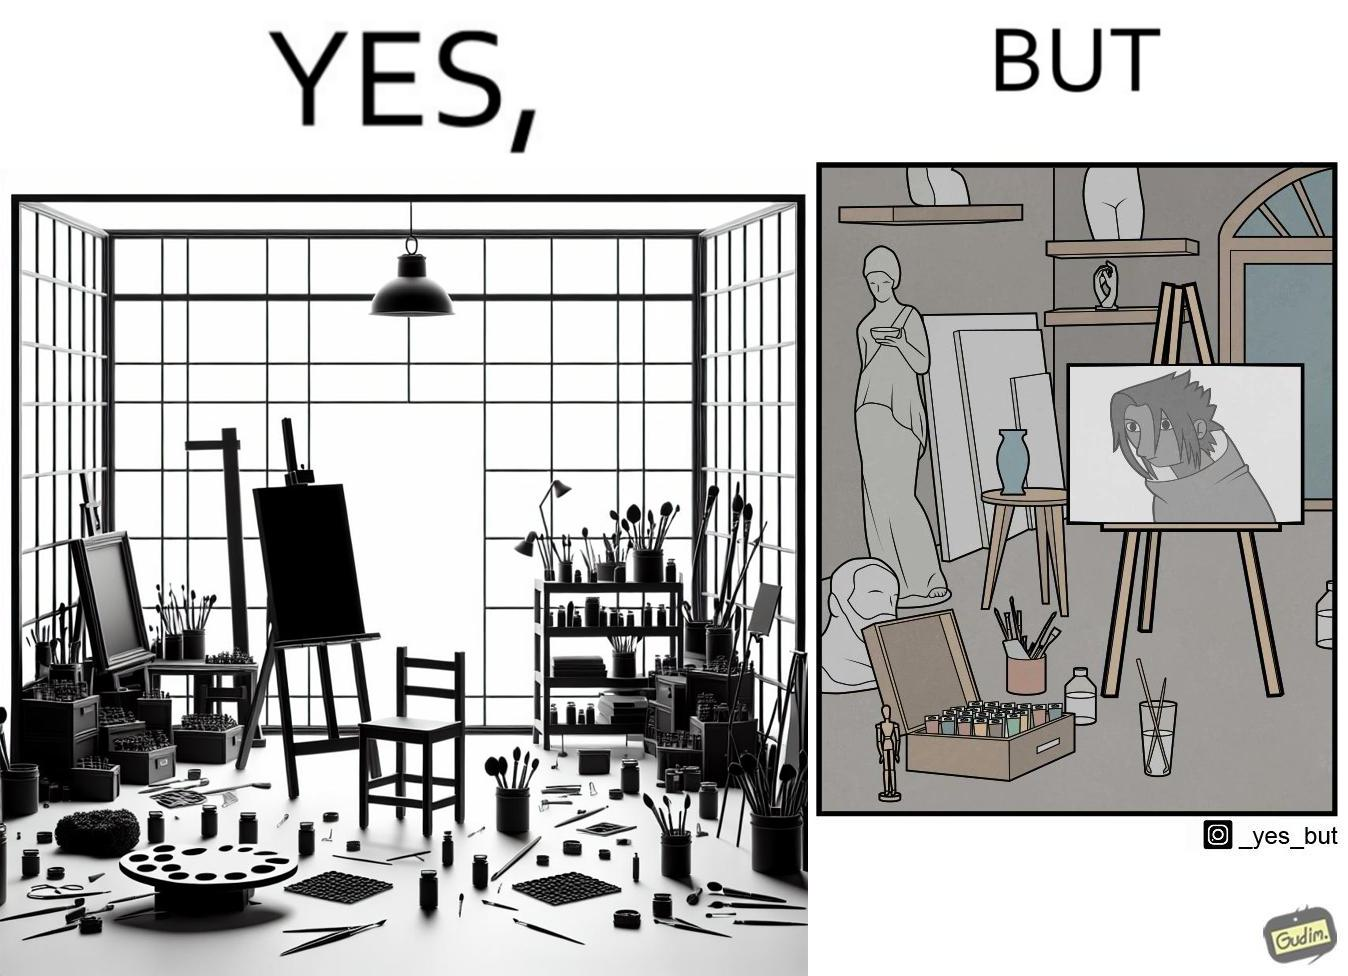What is shown in this image? The image is ironical, as even though the art studio contains a palette of a range of color paints, the painting on the canvas is black and white. 